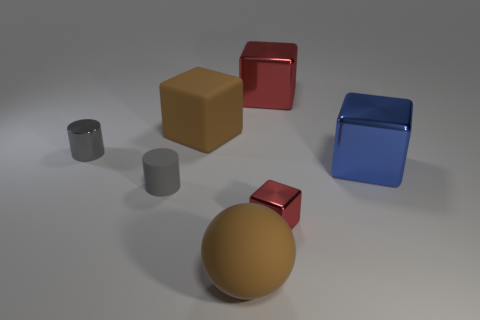Is the large matte sphere the same color as the tiny metallic block?
Ensure brevity in your answer.  No. What is the shape of the red metal thing that is the same size as the gray metal cylinder?
Offer a very short reply. Cube. There is a small cylinder that is the same material as the small red cube; what color is it?
Ensure brevity in your answer.  Gray. Are there fewer big things on the left side of the blue shiny block than tiny purple cylinders?
Give a very brief answer. No. There is a red block that is behind the tiny gray object that is on the right side of the cylinder that is behind the matte cylinder; how big is it?
Make the answer very short. Large. Do the sphere in front of the large brown rubber cube and the brown cube have the same material?
Give a very brief answer. Yes. There is a thing that is the same color as the sphere; what is it made of?
Provide a succinct answer. Rubber. Is there any other thing that is the same shape as the tiny rubber object?
Your response must be concise. Yes. What number of objects are small gray cylinders or red blocks?
Provide a short and direct response. 4. There is another gray object that is the same shape as the gray metal object; what size is it?
Your answer should be compact. Small. 